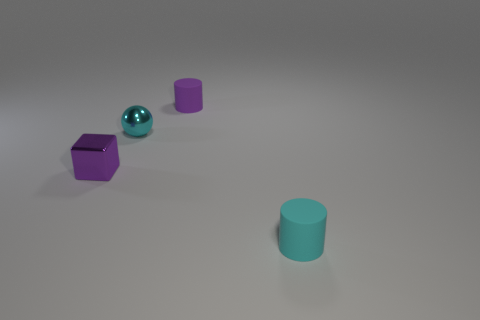Add 1 cyan rubber things. How many objects exist? 5 Subtract all balls. How many objects are left? 3 Subtract 0 yellow spheres. How many objects are left? 4 Subtract all small purple matte spheres. Subtract all tiny cyan balls. How many objects are left? 3 Add 1 tiny metal cubes. How many tiny metal cubes are left? 2 Add 4 brown rubber cubes. How many brown rubber cubes exist? 4 